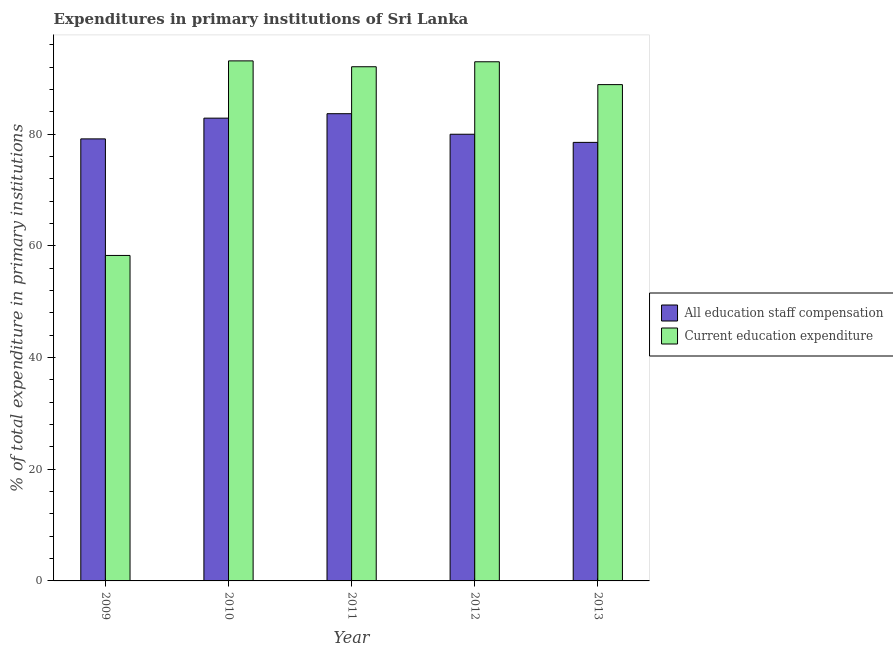How many groups of bars are there?
Give a very brief answer. 5. Are the number of bars per tick equal to the number of legend labels?
Make the answer very short. Yes. How many bars are there on the 5th tick from the left?
Provide a succinct answer. 2. In how many cases, is the number of bars for a given year not equal to the number of legend labels?
Give a very brief answer. 0. What is the expenditure in education in 2012?
Your answer should be very brief. 92.98. Across all years, what is the maximum expenditure in education?
Keep it short and to the point. 93.14. Across all years, what is the minimum expenditure in staff compensation?
Your response must be concise. 78.55. What is the total expenditure in staff compensation in the graph?
Provide a short and direct response. 404.29. What is the difference between the expenditure in education in 2009 and that in 2012?
Give a very brief answer. -34.69. What is the difference between the expenditure in education in 2012 and the expenditure in staff compensation in 2010?
Keep it short and to the point. -0.16. What is the average expenditure in staff compensation per year?
Keep it short and to the point. 80.86. What is the ratio of the expenditure in education in 2009 to that in 2011?
Keep it short and to the point. 0.63. What is the difference between the highest and the second highest expenditure in education?
Your response must be concise. 0.16. What is the difference between the highest and the lowest expenditure in staff compensation?
Provide a succinct answer. 5.14. What does the 1st bar from the left in 2011 represents?
Provide a short and direct response. All education staff compensation. What does the 2nd bar from the right in 2012 represents?
Your answer should be compact. All education staff compensation. How many bars are there?
Your answer should be very brief. 10. Are all the bars in the graph horizontal?
Provide a short and direct response. No. How many years are there in the graph?
Your response must be concise. 5. Are the values on the major ticks of Y-axis written in scientific E-notation?
Your answer should be very brief. No. Does the graph contain grids?
Give a very brief answer. No. Where does the legend appear in the graph?
Keep it short and to the point. Center right. How many legend labels are there?
Keep it short and to the point. 2. What is the title of the graph?
Your answer should be very brief. Expenditures in primary institutions of Sri Lanka. Does "Banks" appear as one of the legend labels in the graph?
Make the answer very short. No. What is the label or title of the X-axis?
Give a very brief answer. Year. What is the label or title of the Y-axis?
Give a very brief answer. % of total expenditure in primary institutions. What is the % of total expenditure in primary institutions of All education staff compensation in 2009?
Make the answer very short. 79.17. What is the % of total expenditure in primary institutions of Current education expenditure in 2009?
Offer a terse response. 58.29. What is the % of total expenditure in primary institutions in All education staff compensation in 2010?
Give a very brief answer. 82.88. What is the % of total expenditure in primary institutions in Current education expenditure in 2010?
Your answer should be very brief. 93.14. What is the % of total expenditure in primary institutions in All education staff compensation in 2011?
Keep it short and to the point. 83.68. What is the % of total expenditure in primary institutions of Current education expenditure in 2011?
Provide a succinct answer. 92.09. What is the % of total expenditure in primary institutions of All education staff compensation in 2012?
Your answer should be very brief. 80. What is the % of total expenditure in primary institutions in Current education expenditure in 2012?
Ensure brevity in your answer.  92.98. What is the % of total expenditure in primary institutions of All education staff compensation in 2013?
Provide a succinct answer. 78.55. What is the % of total expenditure in primary institutions of Current education expenditure in 2013?
Offer a terse response. 88.89. Across all years, what is the maximum % of total expenditure in primary institutions in All education staff compensation?
Provide a short and direct response. 83.68. Across all years, what is the maximum % of total expenditure in primary institutions of Current education expenditure?
Offer a very short reply. 93.14. Across all years, what is the minimum % of total expenditure in primary institutions in All education staff compensation?
Give a very brief answer. 78.55. Across all years, what is the minimum % of total expenditure in primary institutions of Current education expenditure?
Your response must be concise. 58.29. What is the total % of total expenditure in primary institutions in All education staff compensation in the graph?
Provide a succinct answer. 404.29. What is the total % of total expenditure in primary institutions of Current education expenditure in the graph?
Make the answer very short. 425.41. What is the difference between the % of total expenditure in primary institutions of All education staff compensation in 2009 and that in 2010?
Make the answer very short. -3.71. What is the difference between the % of total expenditure in primary institutions in Current education expenditure in 2009 and that in 2010?
Your answer should be compact. -34.85. What is the difference between the % of total expenditure in primary institutions of All education staff compensation in 2009 and that in 2011?
Make the answer very short. -4.51. What is the difference between the % of total expenditure in primary institutions in Current education expenditure in 2009 and that in 2011?
Your response must be concise. -33.8. What is the difference between the % of total expenditure in primary institutions of All education staff compensation in 2009 and that in 2012?
Your response must be concise. -0.83. What is the difference between the % of total expenditure in primary institutions in Current education expenditure in 2009 and that in 2012?
Keep it short and to the point. -34.69. What is the difference between the % of total expenditure in primary institutions in All education staff compensation in 2009 and that in 2013?
Offer a very short reply. 0.63. What is the difference between the % of total expenditure in primary institutions in Current education expenditure in 2009 and that in 2013?
Give a very brief answer. -30.6. What is the difference between the % of total expenditure in primary institutions in All education staff compensation in 2010 and that in 2011?
Your response must be concise. -0.8. What is the difference between the % of total expenditure in primary institutions of Current education expenditure in 2010 and that in 2011?
Offer a terse response. 1.05. What is the difference between the % of total expenditure in primary institutions of All education staff compensation in 2010 and that in 2012?
Your answer should be very brief. 2.88. What is the difference between the % of total expenditure in primary institutions of Current education expenditure in 2010 and that in 2012?
Offer a terse response. 0.16. What is the difference between the % of total expenditure in primary institutions in All education staff compensation in 2010 and that in 2013?
Offer a very short reply. 4.34. What is the difference between the % of total expenditure in primary institutions in Current education expenditure in 2010 and that in 2013?
Make the answer very short. 4.25. What is the difference between the % of total expenditure in primary institutions of All education staff compensation in 2011 and that in 2012?
Offer a terse response. 3.68. What is the difference between the % of total expenditure in primary institutions of Current education expenditure in 2011 and that in 2012?
Keep it short and to the point. -0.89. What is the difference between the % of total expenditure in primary institutions in All education staff compensation in 2011 and that in 2013?
Your answer should be compact. 5.14. What is the difference between the % of total expenditure in primary institutions in Current education expenditure in 2011 and that in 2013?
Keep it short and to the point. 3.2. What is the difference between the % of total expenditure in primary institutions of All education staff compensation in 2012 and that in 2013?
Your answer should be compact. 1.46. What is the difference between the % of total expenditure in primary institutions of Current education expenditure in 2012 and that in 2013?
Make the answer very short. 4.09. What is the difference between the % of total expenditure in primary institutions in All education staff compensation in 2009 and the % of total expenditure in primary institutions in Current education expenditure in 2010?
Offer a terse response. -13.97. What is the difference between the % of total expenditure in primary institutions in All education staff compensation in 2009 and the % of total expenditure in primary institutions in Current education expenditure in 2011?
Give a very brief answer. -12.92. What is the difference between the % of total expenditure in primary institutions of All education staff compensation in 2009 and the % of total expenditure in primary institutions of Current education expenditure in 2012?
Offer a terse response. -13.81. What is the difference between the % of total expenditure in primary institutions of All education staff compensation in 2009 and the % of total expenditure in primary institutions of Current education expenditure in 2013?
Your answer should be compact. -9.72. What is the difference between the % of total expenditure in primary institutions of All education staff compensation in 2010 and the % of total expenditure in primary institutions of Current education expenditure in 2011?
Provide a succinct answer. -9.21. What is the difference between the % of total expenditure in primary institutions of All education staff compensation in 2010 and the % of total expenditure in primary institutions of Current education expenditure in 2012?
Your answer should be very brief. -10.1. What is the difference between the % of total expenditure in primary institutions of All education staff compensation in 2010 and the % of total expenditure in primary institutions of Current education expenditure in 2013?
Keep it short and to the point. -6.01. What is the difference between the % of total expenditure in primary institutions in All education staff compensation in 2011 and the % of total expenditure in primary institutions in Current education expenditure in 2012?
Make the answer very short. -9.3. What is the difference between the % of total expenditure in primary institutions of All education staff compensation in 2011 and the % of total expenditure in primary institutions of Current education expenditure in 2013?
Provide a succinct answer. -5.21. What is the difference between the % of total expenditure in primary institutions of All education staff compensation in 2012 and the % of total expenditure in primary institutions of Current education expenditure in 2013?
Keep it short and to the point. -8.89. What is the average % of total expenditure in primary institutions in All education staff compensation per year?
Give a very brief answer. 80.86. What is the average % of total expenditure in primary institutions of Current education expenditure per year?
Offer a very short reply. 85.08. In the year 2009, what is the difference between the % of total expenditure in primary institutions of All education staff compensation and % of total expenditure in primary institutions of Current education expenditure?
Make the answer very short. 20.88. In the year 2010, what is the difference between the % of total expenditure in primary institutions of All education staff compensation and % of total expenditure in primary institutions of Current education expenditure?
Your answer should be very brief. -10.26. In the year 2011, what is the difference between the % of total expenditure in primary institutions in All education staff compensation and % of total expenditure in primary institutions in Current education expenditure?
Provide a short and direct response. -8.41. In the year 2012, what is the difference between the % of total expenditure in primary institutions in All education staff compensation and % of total expenditure in primary institutions in Current education expenditure?
Your answer should be very brief. -12.98. In the year 2013, what is the difference between the % of total expenditure in primary institutions in All education staff compensation and % of total expenditure in primary institutions in Current education expenditure?
Provide a short and direct response. -10.35. What is the ratio of the % of total expenditure in primary institutions in All education staff compensation in 2009 to that in 2010?
Make the answer very short. 0.96. What is the ratio of the % of total expenditure in primary institutions of Current education expenditure in 2009 to that in 2010?
Offer a terse response. 0.63. What is the ratio of the % of total expenditure in primary institutions in All education staff compensation in 2009 to that in 2011?
Your answer should be very brief. 0.95. What is the ratio of the % of total expenditure in primary institutions of Current education expenditure in 2009 to that in 2011?
Ensure brevity in your answer.  0.63. What is the ratio of the % of total expenditure in primary institutions in All education staff compensation in 2009 to that in 2012?
Give a very brief answer. 0.99. What is the ratio of the % of total expenditure in primary institutions in Current education expenditure in 2009 to that in 2012?
Give a very brief answer. 0.63. What is the ratio of the % of total expenditure in primary institutions in All education staff compensation in 2009 to that in 2013?
Make the answer very short. 1.01. What is the ratio of the % of total expenditure in primary institutions in Current education expenditure in 2009 to that in 2013?
Offer a very short reply. 0.66. What is the ratio of the % of total expenditure in primary institutions of Current education expenditure in 2010 to that in 2011?
Make the answer very short. 1.01. What is the ratio of the % of total expenditure in primary institutions of All education staff compensation in 2010 to that in 2012?
Offer a terse response. 1.04. What is the ratio of the % of total expenditure in primary institutions in All education staff compensation in 2010 to that in 2013?
Make the answer very short. 1.06. What is the ratio of the % of total expenditure in primary institutions in Current education expenditure in 2010 to that in 2013?
Give a very brief answer. 1.05. What is the ratio of the % of total expenditure in primary institutions of All education staff compensation in 2011 to that in 2012?
Offer a terse response. 1.05. What is the ratio of the % of total expenditure in primary institutions in All education staff compensation in 2011 to that in 2013?
Provide a succinct answer. 1.07. What is the ratio of the % of total expenditure in primary institutions of Current education expenditure in 2011 to that in 2013?
Your answer should be very brief. 1.04. What is the ratio of the % of total expenditure in primary institutions in All education staff compensation in 2012 to that in 2013?
Your response must be concise. 1.02. What is the ratio of the % of total expenditure in primary institutions in Current education expenditure in 2012 to that in 2013?
Give a very brief answer. 1.05. What is the difference between the highest and the second highest % of total expenditure in primary institutions of All education staff compensation?
Offer a terse response. 0.8. What is the difference between the highest and the second highest % of total expenditure in primary institutions of Current education expenditure?
Keep it short and to the point. 0.16. What is the difference between the highest and the lowest % of total expenditure in primary institutions of All education staff compensation?
Keep it short and to the point. 5.14. What is the difference between the highest and the lowest % of total expenditure in primary institutions of Current education expenditure?
Your answer should be very brief. 34.85. 